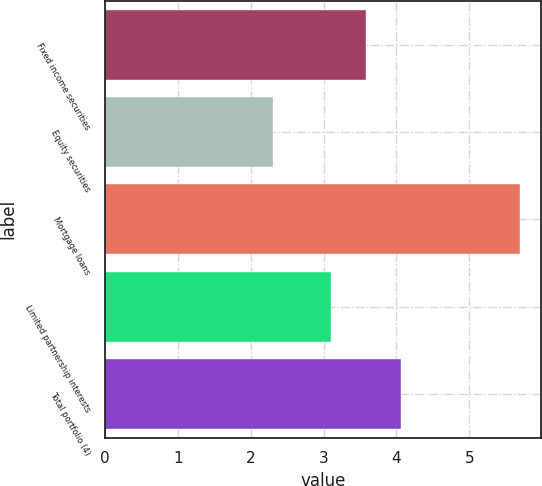Convert chart. <chart><loc_0><loc_0><loc_500><loc_500><bar_chart><fcel>Fixed income securities<fcel>Equity securities<fcel>Mortgage loans<fcel>Limited partnership interests<fcel>Total portfolio (4)<nl><fcel>3.58<fcel>2.3<fcel>5.7<fcel>3.1<fcel>4.06<nl></chart> 